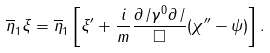<formula> <loc_0><loc_0><loc_500><loc_500>\overline { \eta } _ { 1 } \xi = \overline { \eta } _ { 1 } \left [ \xi ^ { \prime } + \frac { i } { m } \frac { \partial \, / \gamma ^ { 0 } \partial \, / } { \Box } ( \chi ^ { \prime \prime } - \psi ) \right ] .</formula> 